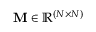<formula> <loc_0><loc_0><loc_500><loc_500>{ M } \in \mathbb { R } ^ { ( N \times N ) }</formula> 